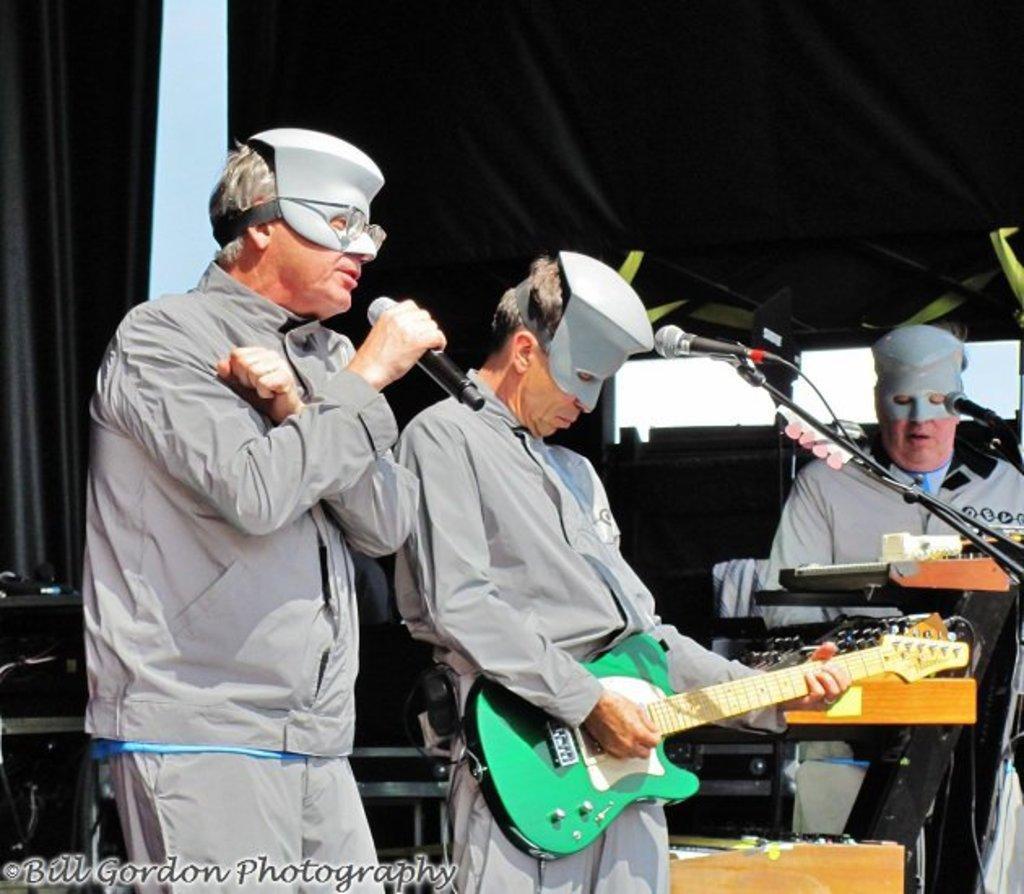How would you summarize this image in a sentence or two? In this picture we can see three persons on left side person holding mic and singing on it and in middle person holding guitar and playing and on right side person sitting on chair and playing piano and in background we can see curtains. 